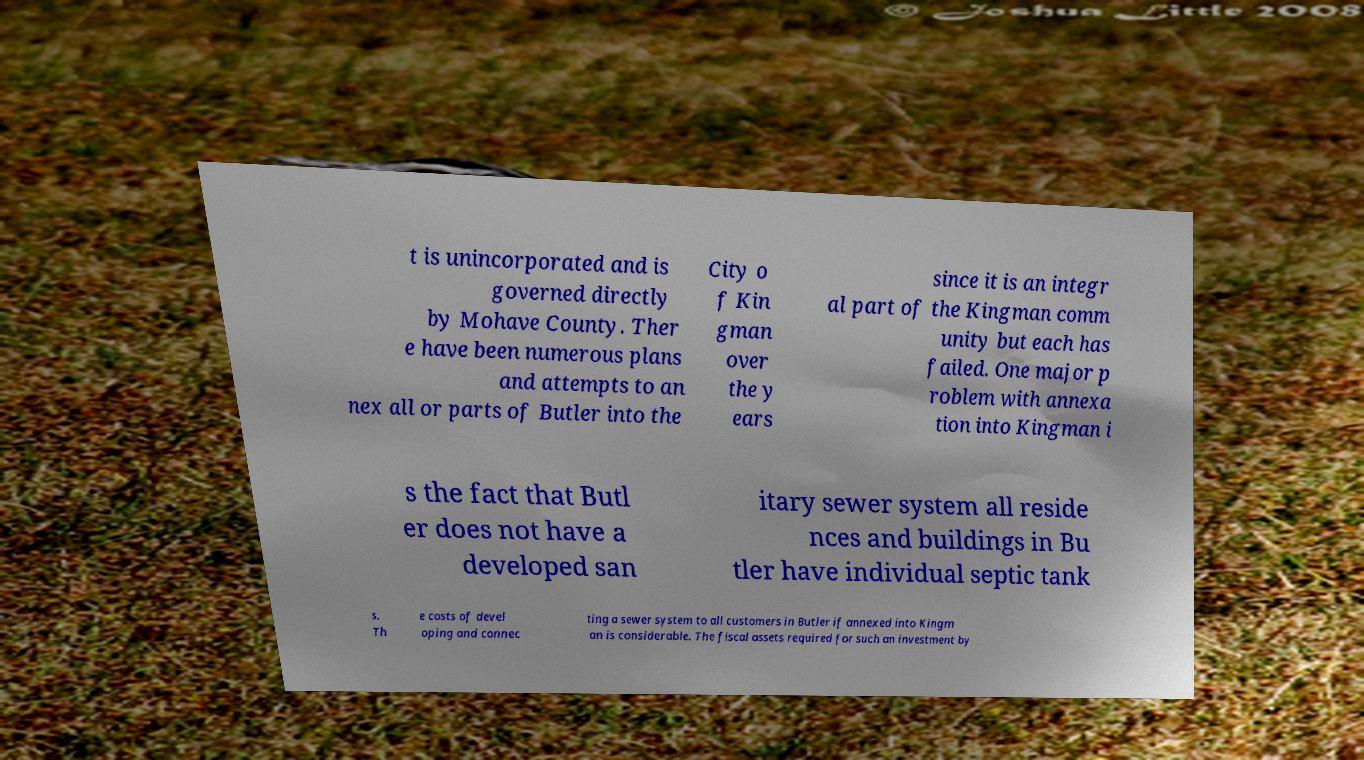There's text embedded in this image that I need extracted. Can you transcribe it verbatim? t is unincorporated and is governed directly by Mohave County. Ther e have been numerous plans and attempts to an nex all or parts of Butler into the City o f Kin gman over the y ears since it is an integr al part of the Kingman comm unity but each has failed. One major p roblem with annexa tion into Kingman i s the fact that Butl er does not have a developed san itary sewer system all reside nces and buildings in Bu tler have individual septic tank s. Th e costs of devel oping and connec ting a sewer system to all customers in Butler if annexed into Kingm an is considerable. The fiscal assets required for such an investment by 